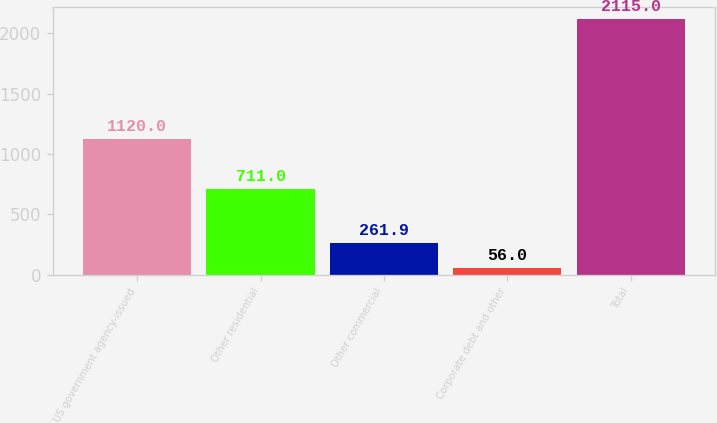Convert chart to OTSL. <chart><loc_0><loc_0><loc_500><loc_500><bar_chart><fcel>US government agency-issued<fcel>Other residential<fcel>Other commercial<fcel>Corporate debt and other<fcel>Total<nl><fcel>1120<fcel>711<fcel>261.9<fcel>56<fcel>2115<nl></chart> 